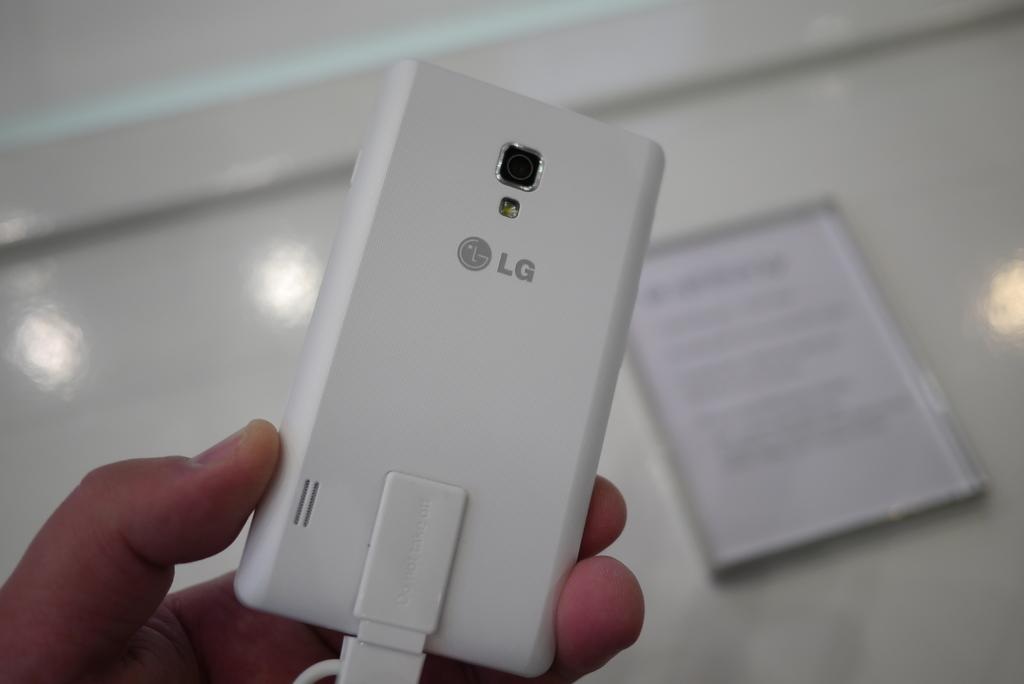<image>
Provide a brief description of the given image. A hand holds an LG phone that is entirely white in color. 